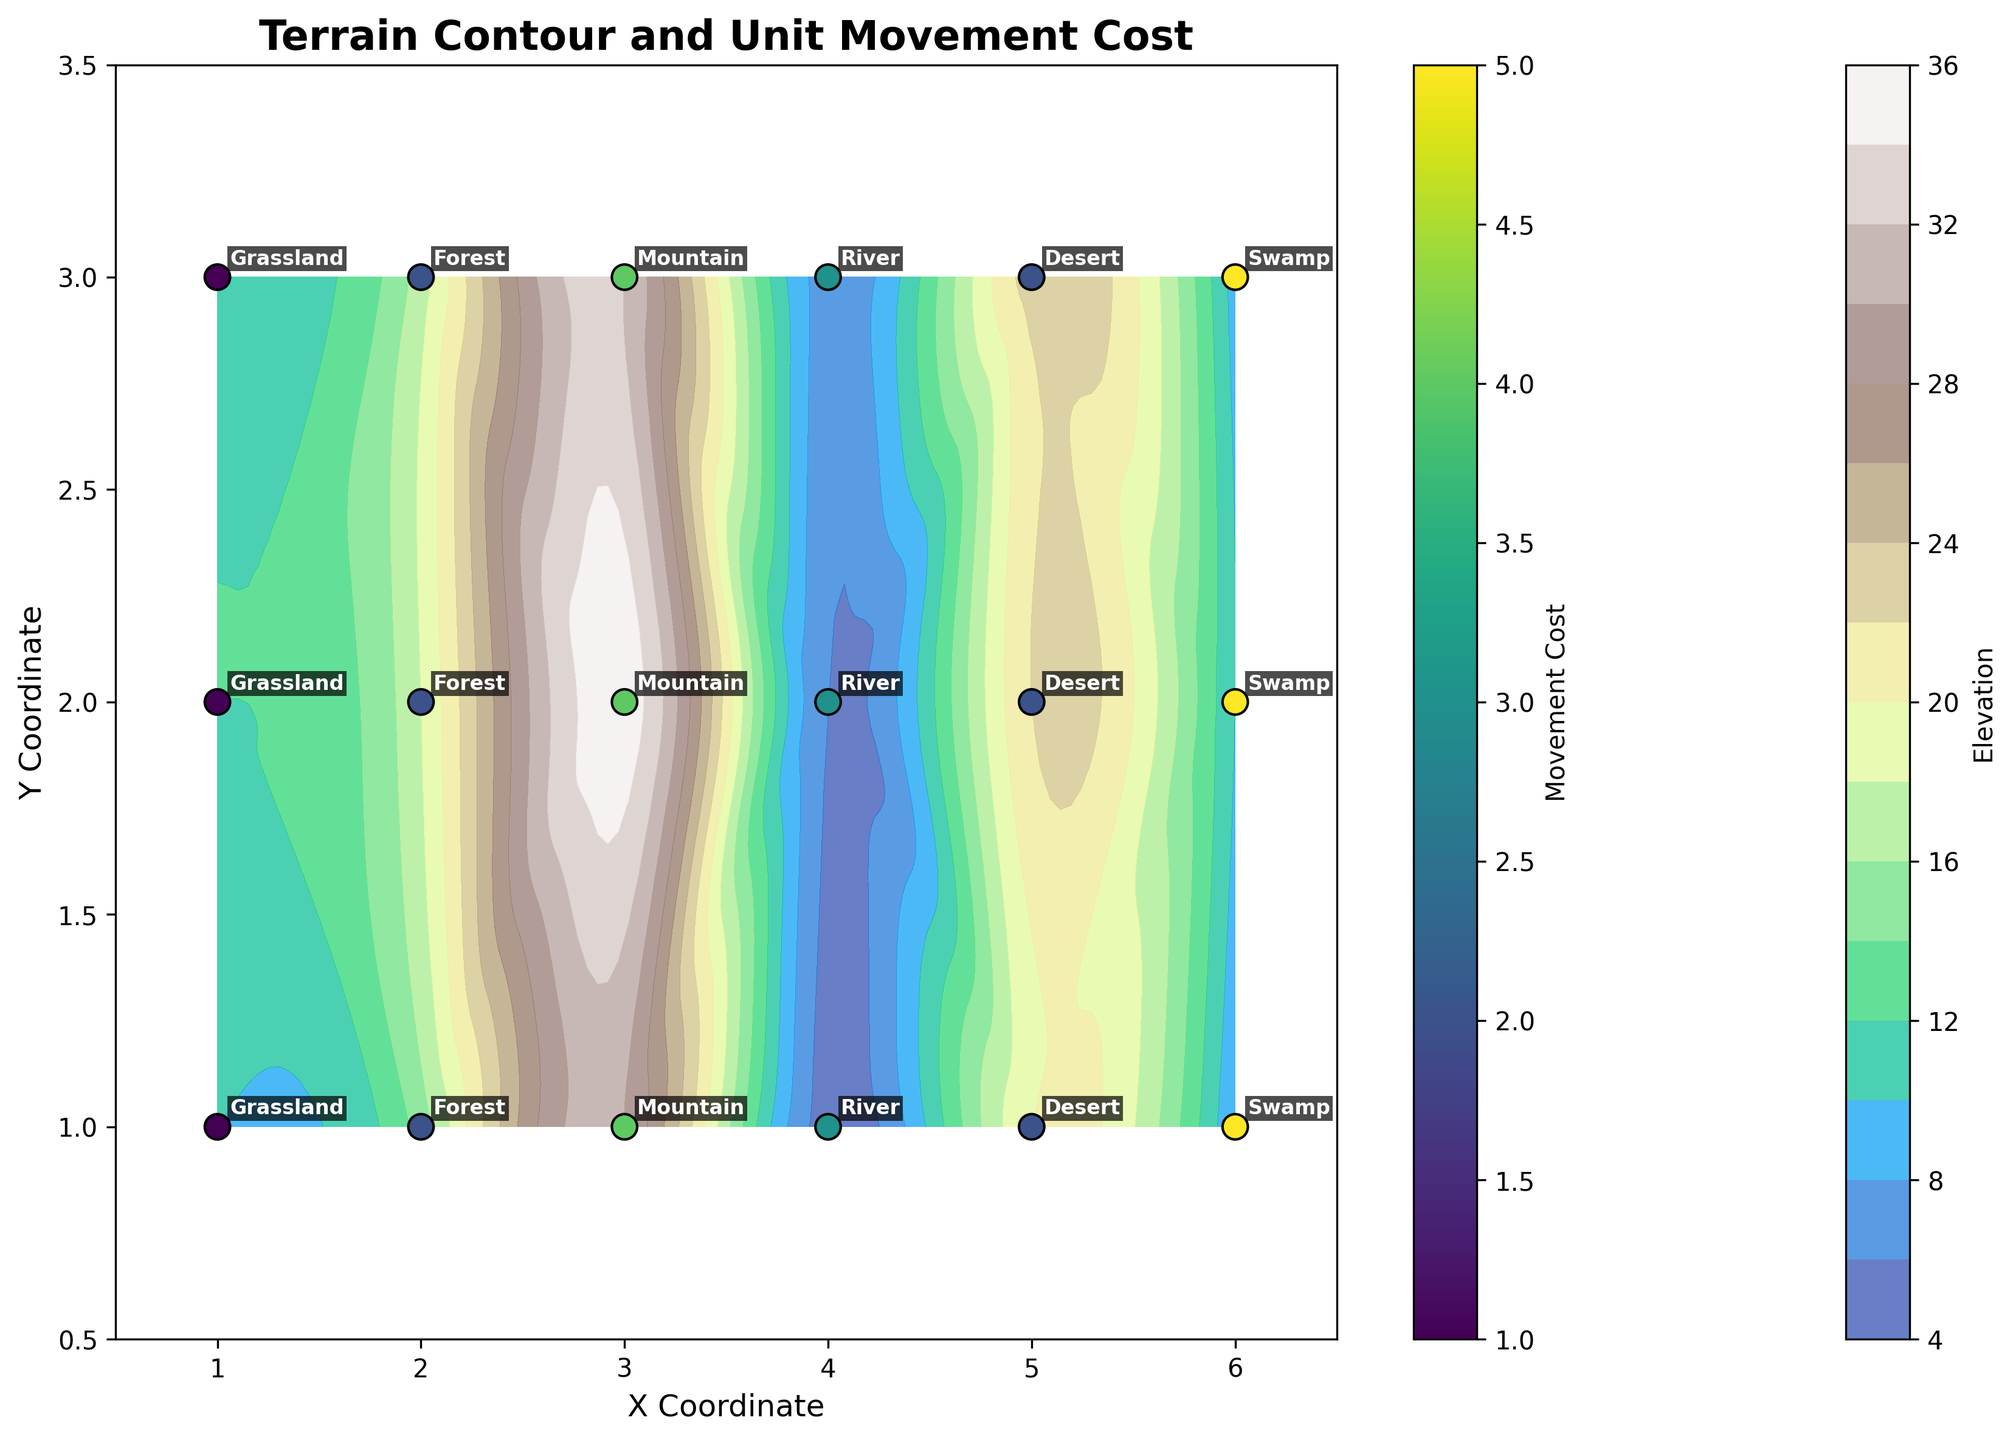What is the title of the figure? The title of the figure is displayed prominently at the top and provides a summary of the content it represents.
Answer: Terrain Contour and Unit Movement Cost What does the color gradient in the contour represent? The color gradient in the contour plot typically represents the elevation levels, with varying shades indicating different heights.
Answer: Elevation How many different terrains are labeled in the plot? By counting the distinct terrain labels annotated in the plot, we can determine the total number of unique terrains. The figure includes Grassland, Forest, Mountain, River, Desert, and Swamp.
Answer: Six Which terrain has the highest movement cost? Among the terrains labeled in the plot, the movement cost is visually represented by the color of the scatter points. Swamp has the highest movement cost as indicated by the darkest scatter points.
Answer: Swamp What is the elevation range for the Mountain terrain? To determine the elevation range for Mountain terrain, we observe the contour levels and the specific elevation values around the Mountain locations. It ranges from 30 to 35.
Answer: 30 to 35 Which terrain has the lowest elevation? We pinpoint the terrain where the contour colors are at their lightest, indicating the lowest elevation. The River terrain has the lowest elevation as shown by the lightest color on the contour plot.
Answer: River Compare the movement costs between Grassland and Forest terrains. Which one allows faster movement? By comparing the colors of the scatter points representing movement costs for Grassland and Forest, we see Grassland (lighter color) has a movement cost of 1, whereas Forest (darker color) has a movement cost of 2, indicating Grassland allows faster movement.
Answer: Grassland Is there a correlation between elevation and movement cost for any terrain? Observing the contour and scatter plots for each terrain, we check if higher elevation consistently leads to higher movement costs within a terrain. For the Swamp terrain, this correlation is visible as it has high elevation and movement cost.
Answer: Yes, in Swamp Identify the terrain with both low elevation and low movement cost. By examining the entire figure for contours with lower elevation colors and scatter points with lighter color for movement cost, we find that Grassland fits these criteria.
Answer: Grassland How does the movement cost change as you move from Coordinate (1,1) to Coordinate (6,1)? Tracing the scatter points along the y=1 axis from x=1 to x=6, we observe the colors representing movement costs. Movement starts at 1 on Grassland, increases to 2 (Forest), peaks at 4 (Mountain), drops to 3 (River), returns to 2 (Desert), and finally peaks at 5 (Swamp).
Answer: 1 → 2 → 4 → 3 → 2 → 5 